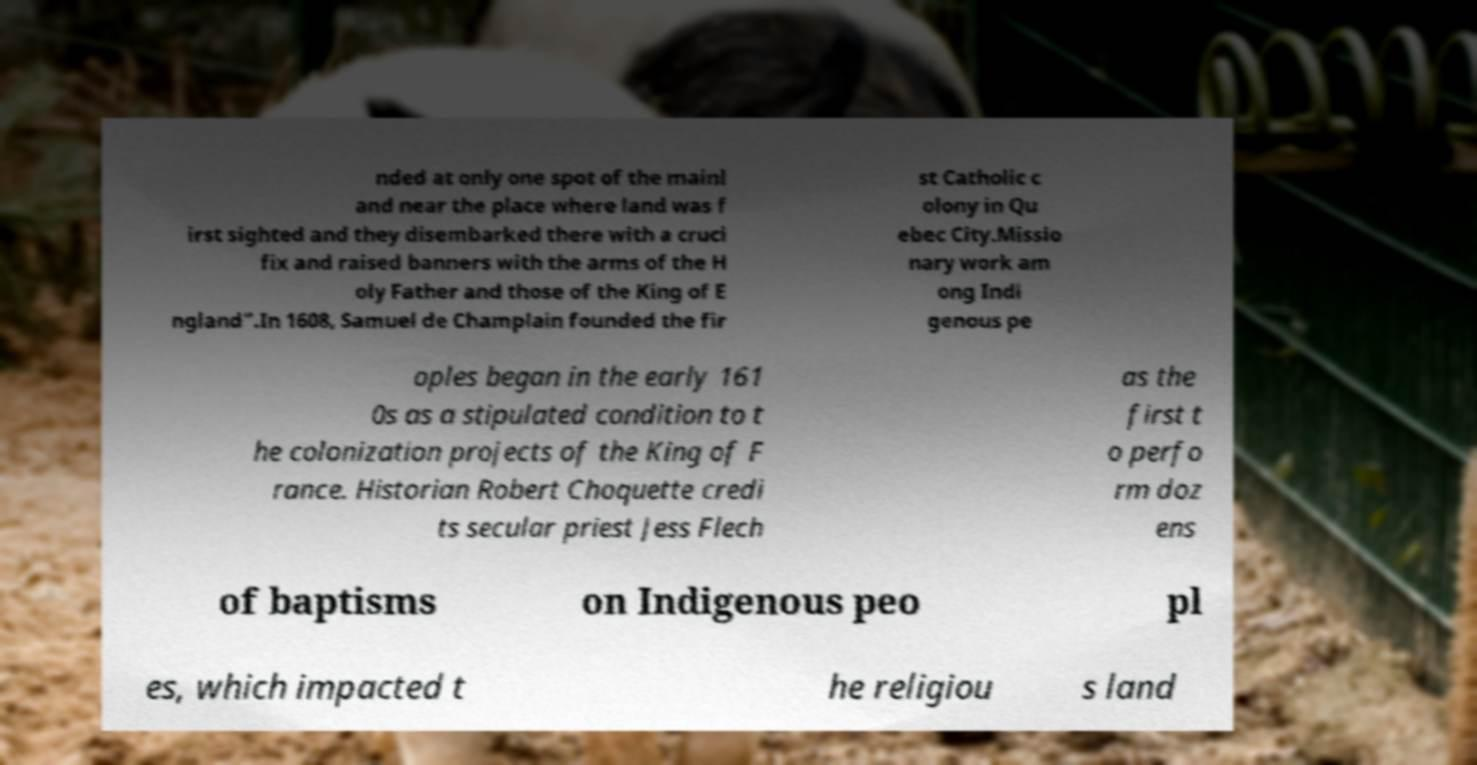For documentation purposes, I need the text within this image transcribed. Could you provide that? nded at only one spot of the mainl and near the place where land was f irst sighted and they disembarked there with a cruci fix and raised banners with the arms of the H oly Father and those of the King of E ngland".In 1608, Samuel de Champlain founded the fir st Catholic c olony in Qu ebec City.Missio nary work am ong Indi genous pe oples began in the early 161 0s as a stipulated condition to t he colonization projects of the King of F rance. Historian Robert Choquette credi ts secular priest Jess Flech as the first t o perfo rm doz ens of baptisms on Indigenous peo pl es, which impacted t he religiou s land 